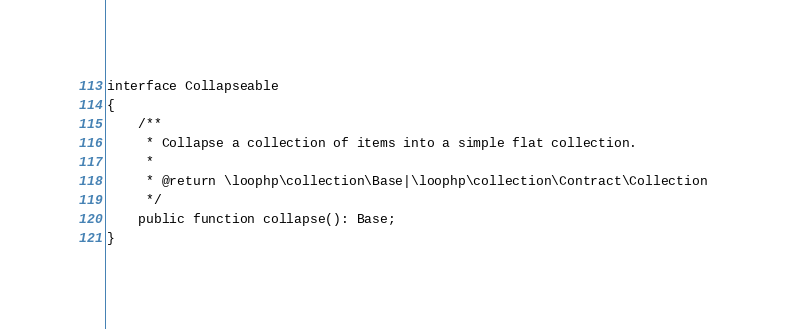<code> <loc_0><loc_0><loc_500><loc_500><_PHP_>
interface Collapseable
{
    /**
     * Collapse a collection of items into a simple flat collection.
     *
     * @return \loophp\collection\Base|\loophp\collection\Contract\Collection
     */
    public function collapse(): Base;
}
</code> 